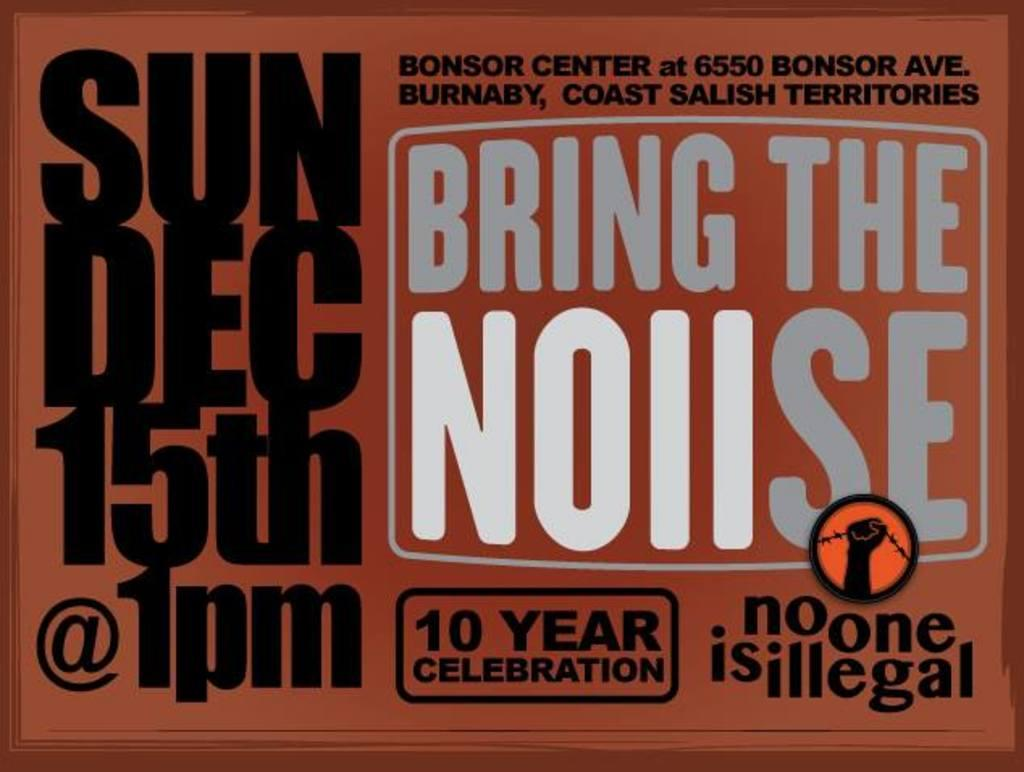Provide a one-sentence caption for the provided image. a big sign ad that says bring the noise 10 year celbration. 